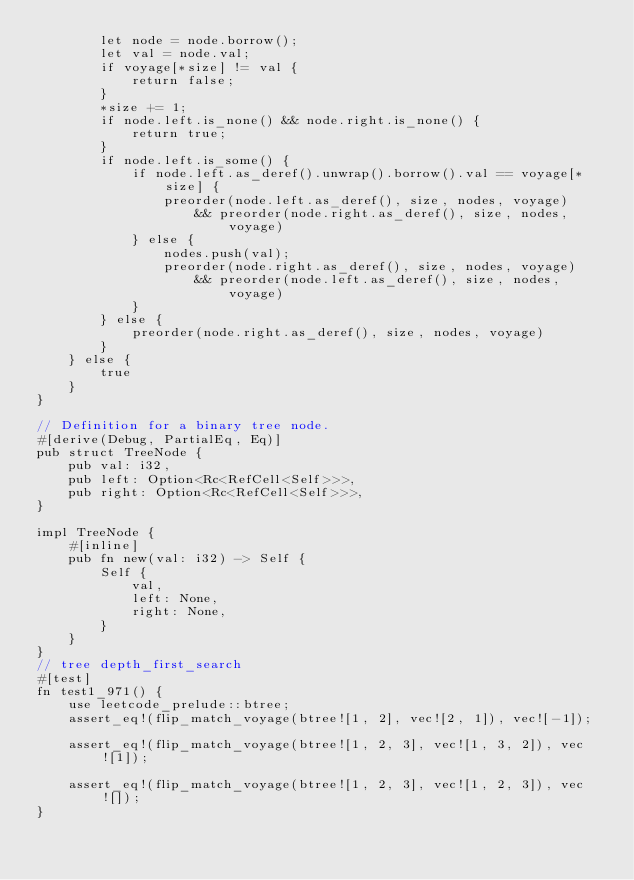Convert code to text. <code><loc_0><loc_0><loc_500><loc_500><_Rust_>        let node = node.borrow();
        let val = node.val;
        if voyage[*size] != val {
            return false;
        }
        *size += 1;
        if node.left.is_none() && node.right.is_none() {
            return true;
        }
        if node.left.is_some() {
            if node.left.as_deref().unwrap().borrow().val == voyage[*size] {
                preorder(node.left.as_deref(), size, nodes, voyage)
                    && preorder(node.right.as_deref(), size, nodes, voyage)
            } else {
                nodes.push(val);
                preorder(node.right.as_deref(), size, nodes, voyage)
                    && preorder(node.left.as_deref(), size, nodes, voyage)
            }
        } else {
            preorder(node.right.as_deref(), size, nodes, voyage)
        }
    } else {
        true
    }
}

// Definition for a binary tree node.
#[derive(Debug, PartialEq, Eq)]
pub struct TreeNode {
    pub val: i32,
    pub left: Option<Rc<RefCell<Self>>>,
    pub right: Option<Rc<RefCell<Self>>>,
}

impl TreeNode {
    #[inline]
    pub fn new(val: i32) -> Self {
        Self {
            val,
            left: None,
            right: None,
        }
    }
}
// tree depth_first_search
#[test]
fn test1_971() {
    use leetcode_prelude::btree;
    assert_eq!(flip_match_voyage(btree![1, 2], vec![2, 1]), vec![-1]);

    assert_eq!(flip_match_voyage(btree![1, 2, 3], vec![1, 3, 2]), vec![1]);

    assert_eq!(flip_match_voyage(btree![1, 2, 3], vec![1, 2, 3]), vec![]);
}
</code> 